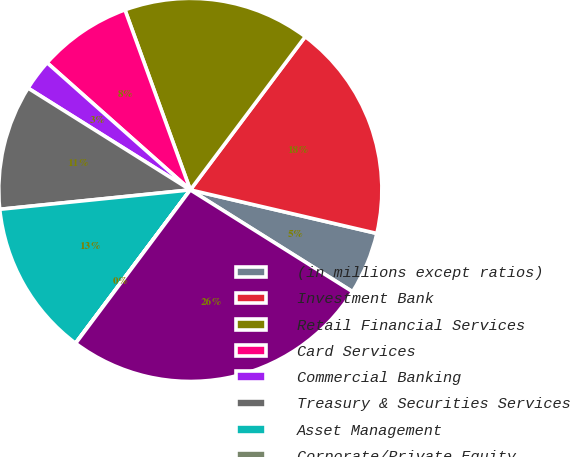Convert chart to OTSL. <chart><loc_0><loc_0><loc_500><loc_500><pie_chart><fcel>(in millions except ratios)<fcel>Investment Bank<fcel>Retail Financial Services<fcel>Card Services<fcel>Commercial Banking<fcel>Treasury & Securities Services<fcel>Asset Management<fcel>Corporate/Private Equity<fcel>Total<nl><fcel>5.27%<fcel>18.41%<fcel>15.78%<fcel>7.9%<fcel>2.64%<fcel>10.53%<fcel>13.15%<fcel>0.02%<fcel>26.29%<nl></chart> 